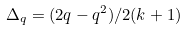<formula> <loc_0><loc_0><loc_500><loc_500>\Delta _ { q } = ( 2 q - q ^ { 2 } ) / 2 ( k + 1 )</formula> 